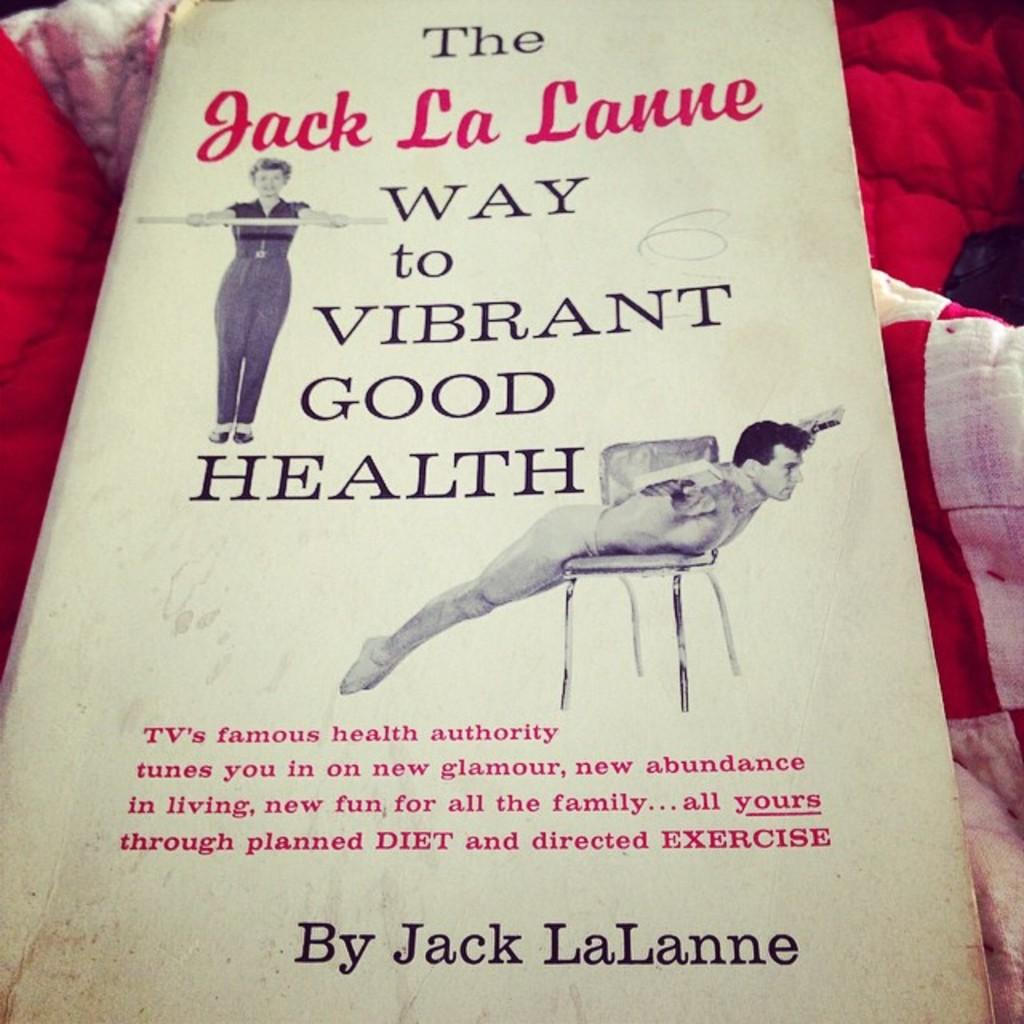What is the main object in the image? There is a book in the image. What can be found on the pages of the book? The book has text and pictures on it. What is located beneath the book? There are blankets below the book. What type of steel material is used to construct the book in the image? There is no steel material used to construct the book in the image; it is made of paper and possibly a hardcover. 